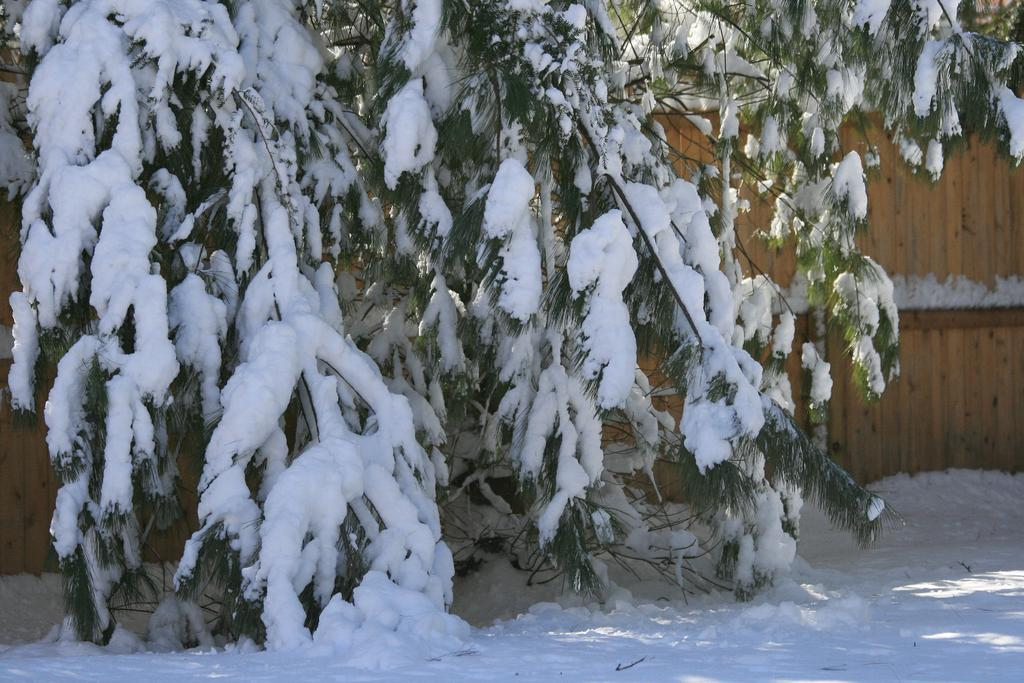What type of weather condition is depicted in the image? There is snow on the tree in the image, indicating a winter scene. What can be seen on the right side of the image? There is a wooden wall on the right side of the image. What type of game is being played in the image? There is no game being played in the image; it features a snowy scene with a tree and a wooden wall. How deep is the mine in the image? There is no mine present in the image; it only shows a tree with snow and a wooden wall. 